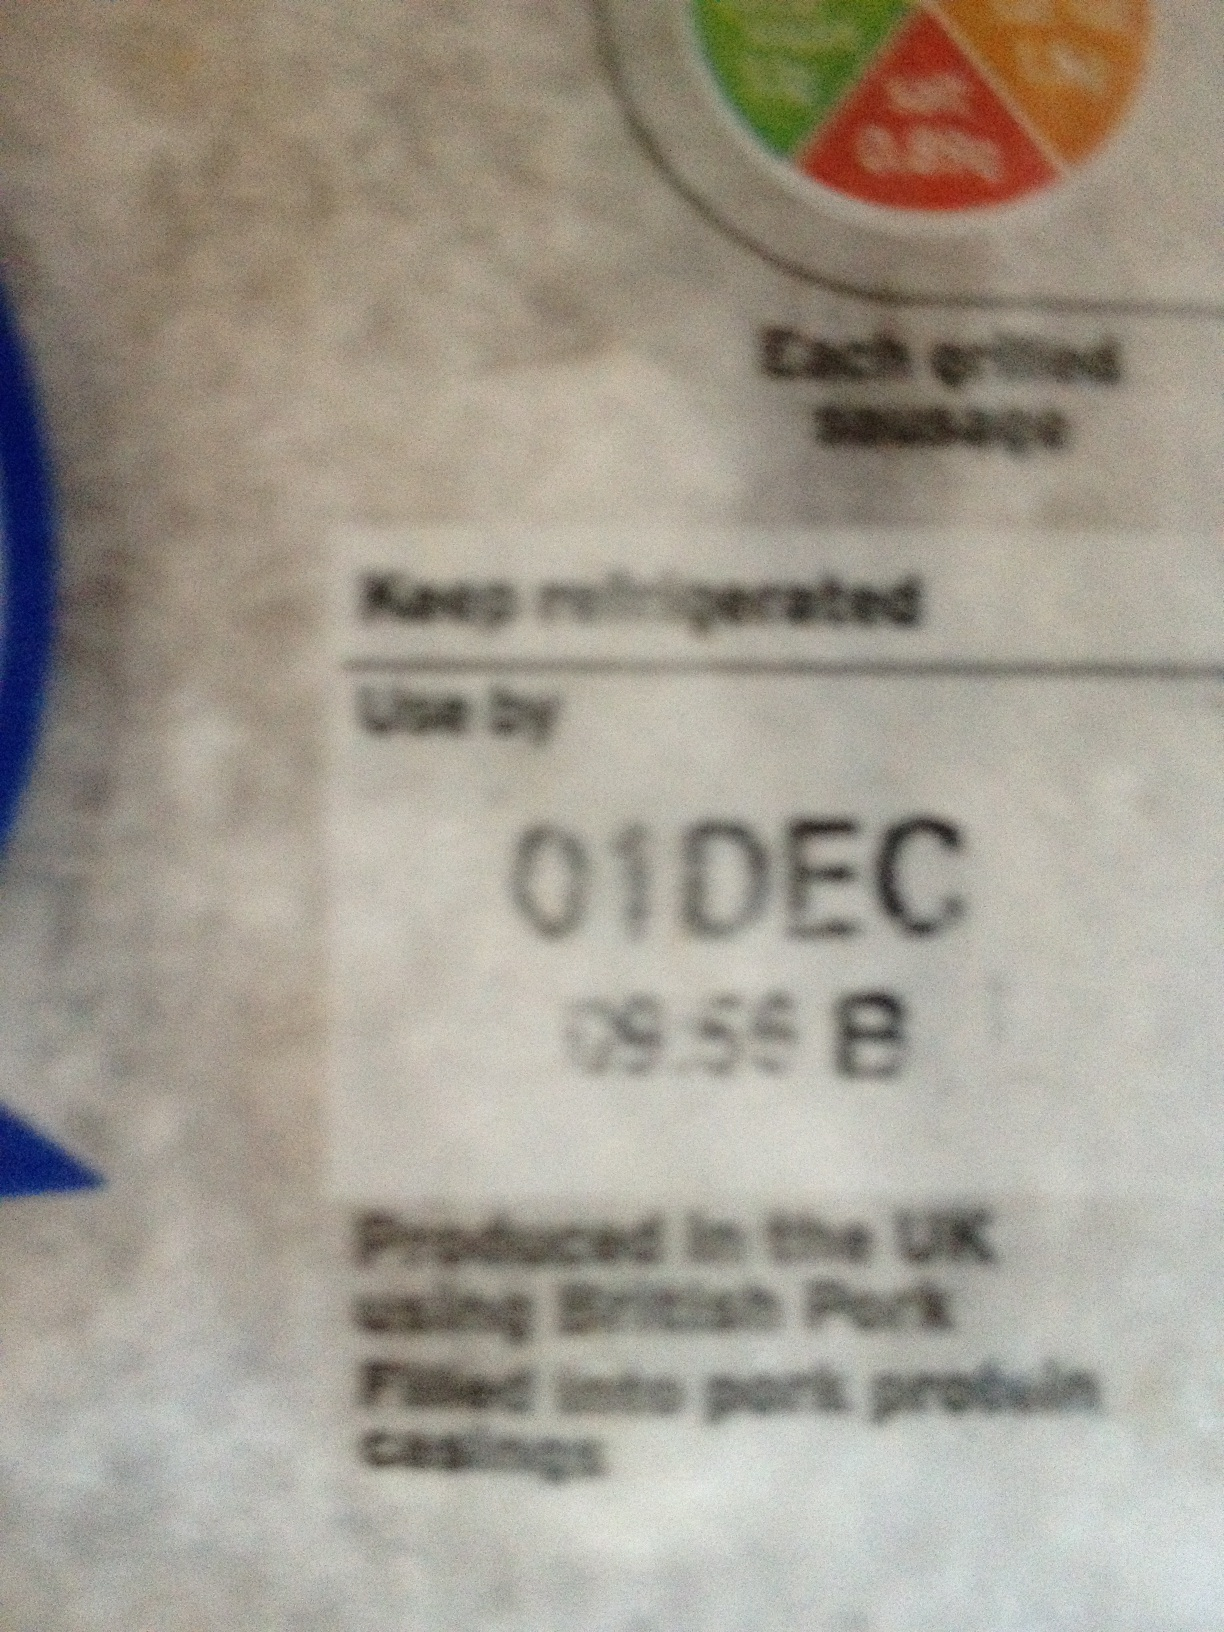What is the shelf life of this product? The shelf life of this product extends until December 1st, as indicated by the 'Use by' date on the label. Make sure to consume it before this date and keep it refrigerated to maintain its quality. What happens if I eat it after the use by date? Eating the product after the 'Use by' date is not advisable. It could potentially be unsafe due to the growth of harmful bacteria. To avoid health risks, always follow the 'Use by' guidelines. 